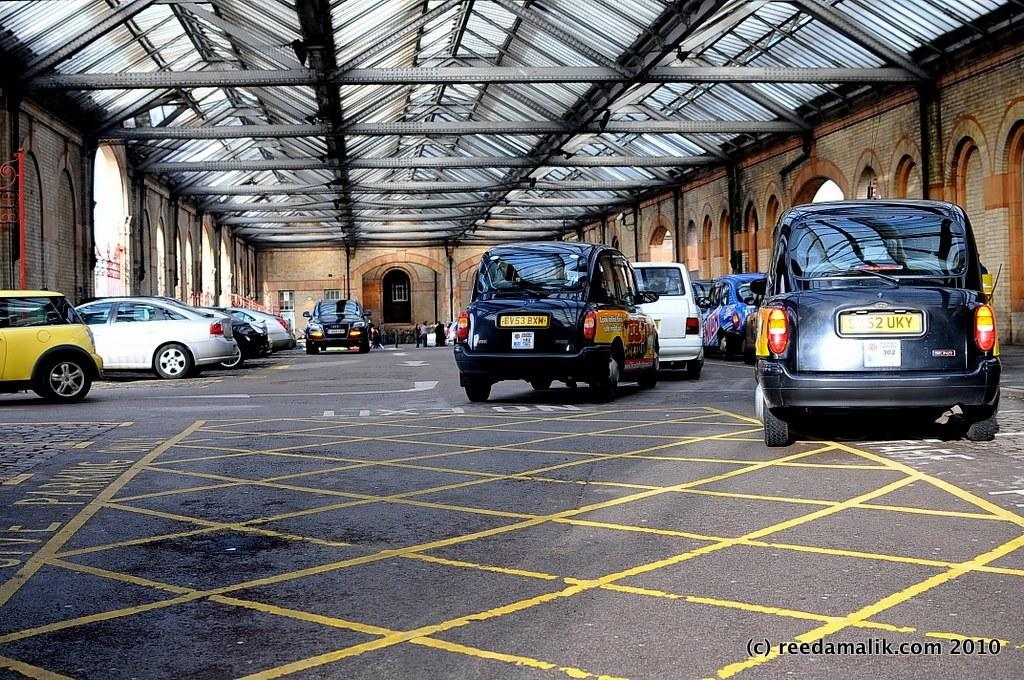<image>
Create a compact narrative representing the image presented. a garage parking lot with one car having a licence plate 6v53bxm 